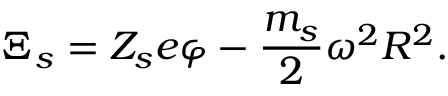Convert formula to latex. <formula><loc_0><loc_0><loc_500><loc_500>\Xi _ { s } = Z _ { s } e \varphi - \frac { m _ { s } } { 2 } \omega ^ { 2 } R ^ { 2 } .</formula> 